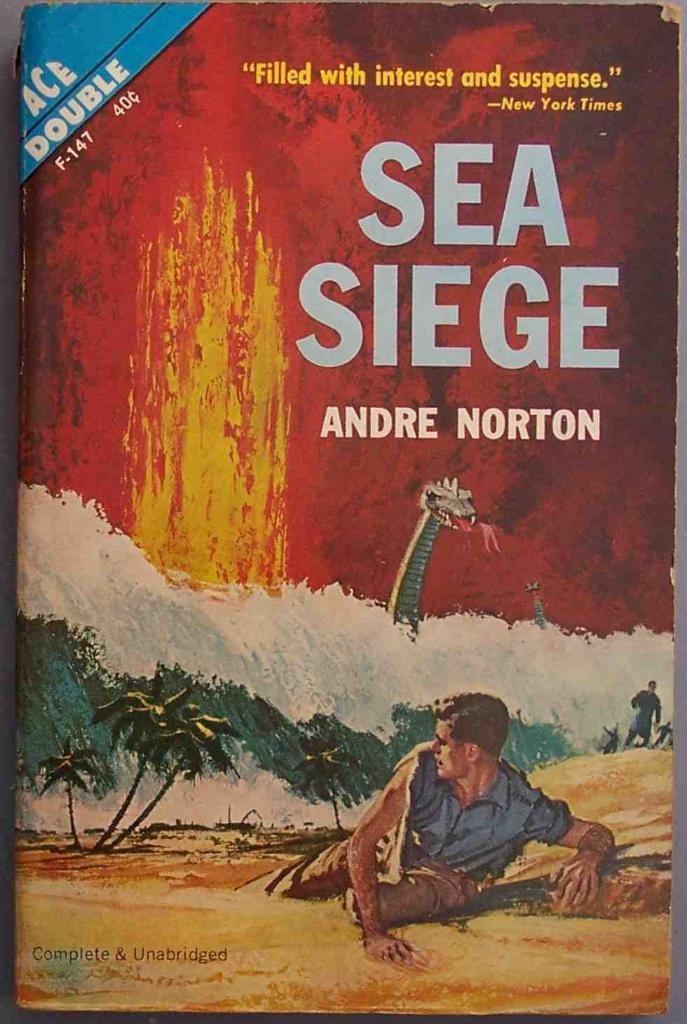<image>
Share a concise interpretation of the image provided. the cover of SEA SIEGE book by Andre Norton 